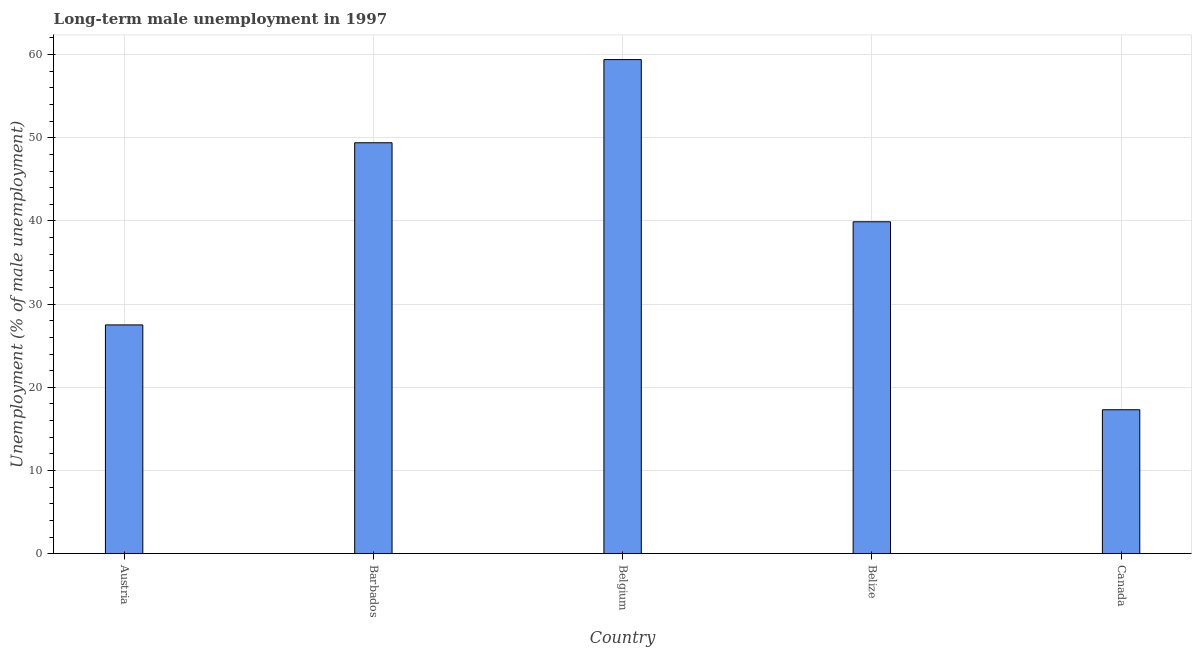Does the graph contain any zero values?
Offer a terse response. No. What is the title of the graph?
Your answer should be very brief. Long-term male unemployment in 1997. What is the label or title of the Y-axis?
Provide a short and direct response. Unemployment (% of male unemployment). What is the long-term male unemployment in Barbados?
Ensure brevity in your answer.  49.4. Across all countries, what is the maximum long-term male unemployment?
Ensure brevity in your answer.  59.4. Across all countries, what is the minimum long-term male unemployment?
Offer a terse response. 17.3. In which country was the long-term male unemployment maximum?
Provide a succinct answer. Belgium. In which country was the long-term male unemployment minimum?
Your answer should be very brief. Canada. What is the sum of the long-term male unemployment?
Offer a very short reply. 193.5. What is the average long-term male unemployment per country?
Keep it short and to the point. 38.7. What is the median long-term male unemployment?
Keep it short and to the point. 39.9. What is the ratio of the long-term male unemployment in Belize to that in Canada?
Offer a very short reply. 2.31. Is the long-term male unemployment in Austria less than that in Barbados?
Make the answer very short. Yes. What is the difference between the highest and the second highest long-term male unemployment?
Ensure brevity in your answer.  10. What is the difference between the highest and the lowest long-term male unemployment?
Offer a very short reply. 42.1. In how many countries, is the long-term male unemployment greater than the average long-term male unemployment taken over all countries?
Your response must be concise. 3. How many bars are there?
Give a very brief answer. 5. What is the difference between two consecutive major ticks on the Y-axis?
Keep it short and to the point. 10. What is the Unemployment (% of male unemployment) of Austria?
Offer a terse response. 27.5. What is the Unemployment (% of male unemployment) in Barbados?
Provide a succinct answer. 49.4. What is the Unemployment (% of male unemployment) of Belgium?
Offer a terse response. 59.4. What is the Unemployment (% of male unemployment) of Belize?
Your answer should be very brief. 39.9. What is the Unemployment (% of male unemployment) in Canada?
Ensure brevity in your answer.  17.3. What is the difference between the Unemployment (% of male unemployment) in Austria and Barbados?
Make the answer very short. -21.9. What is the difference between the Unemployment (% of male unemployment) in Austria and Belgium?
Offer a very short reply. -31.9. What is the difference between the Unemployment (% of male unemployment) in Austria and Canada?
Provide a succinct answer. 10.2. What is the difference between the Unemployment (% of male unemployment) in Barbados and Belgium?
Your response must be concise. -10. What is the difference between the Unemployment (% of male unemployment) in Barbados and Belize?
Provide a succinct answer. 9.5. What is the difference between the Unemployment (% of male unemployment) in Barbados and Canada?
Make the answer very short. 32.1. What is the difference between the Unemployment (% of male unemployment) in Belgium and Belize?
Keep it short and to the point. 19.5. What is the difference between the Unemployment (% of male unemployment) in Belgium and Canada?
Keep it short and to the point. 42.1. What is the difference between the Unemployment (% of male unemployment) in Belize and Canada?
Offer a very short reply. 22.6. What is the ratio of the Unemployment (% of male unemployment) in Austria to that in Barbados?
Provide a succinct answer. 0.56. What is the ratio of the Unemployment (% of male unemployment) in Austria to that in Belgium?
Offer a terse response. 0.46. What is the ratio of the Unemployment (% of male unemployment) in Austria to that in Belize?
Ensure brevity in your answer.  0.69. What is the ratio of the Unemployment (% of male unemployment) in Austria to that in Canada?
Keep it short and to the point. 1.59. What is the ratio of the Unemployment (% of male unemployment) in Barbados to that in Belgium?
Offer a very short reply. 0.83. What is the ratio of the Unemployment (% of male unemployment) in Barbados to that in Belize?
Keep it short and to the point. 1.24. What is the ratio of the Unemployment (% of male unemployment) in Barbados to that in Canada?
Your response must be concise. 2.85. What is the ratio of the Unemployment (% of male unemployment) in Belgium to that in Belize?
Ensure brevity in your answer.  1.49. What is the ratio of the Unemployment (% of male unemployment) in Belgium to that in Canada?
Your answer should be very brief. 3.43. What is the ratio of the Unemployment (% of male unemployment) in Belize to that in Canada?
Offer a terse response. 2.31. 